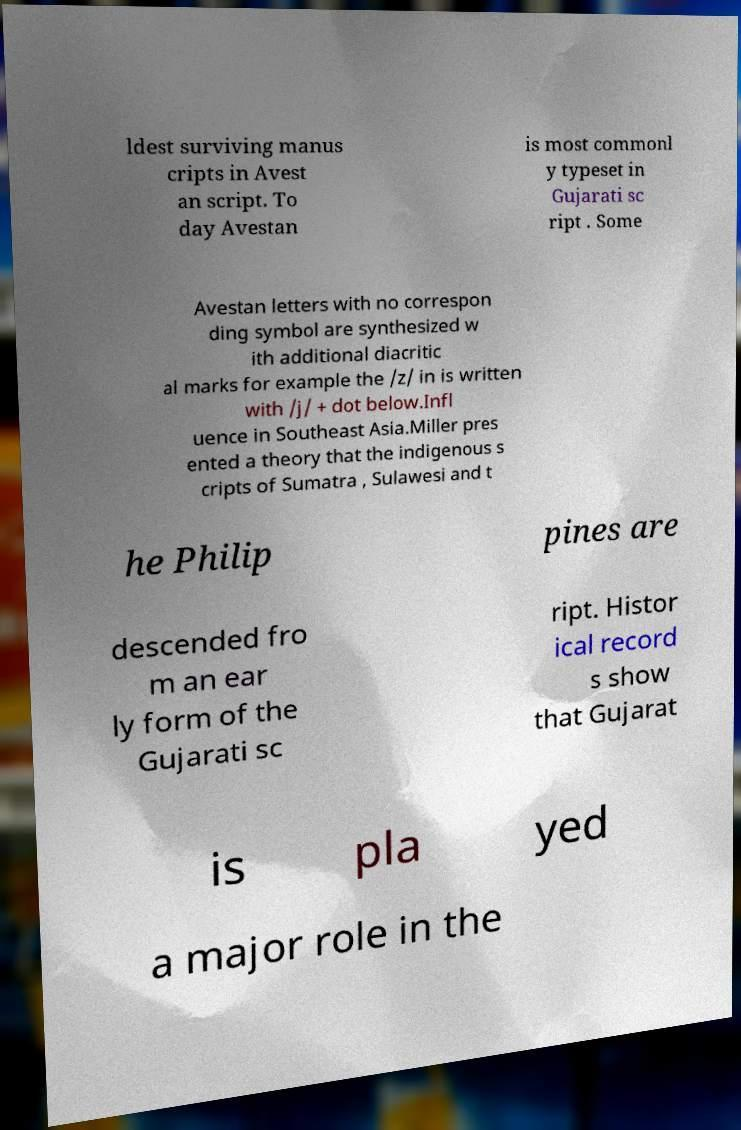What messages or text are displayed in this image? I need them in a readable, typed format. ldest surviving manus cripts in Avest an script. To day Avestan is most commonl y typeset in Gujarati sc ript . Some Avestan letters with no correspon ding symbol are synthesized w ith additional diacritic al marks for example the /z/ in is written with /j/ + dot below.Infl uence in Southeast Asia.Miller pres ented a theory that the indigenous s cripts of Sumatra , Sulawesi and t he Philip pines are descended fro m an ear ly form of the Gujarati sc ript. Histor ical record s show that Gujarat is pla yed a major role in the 